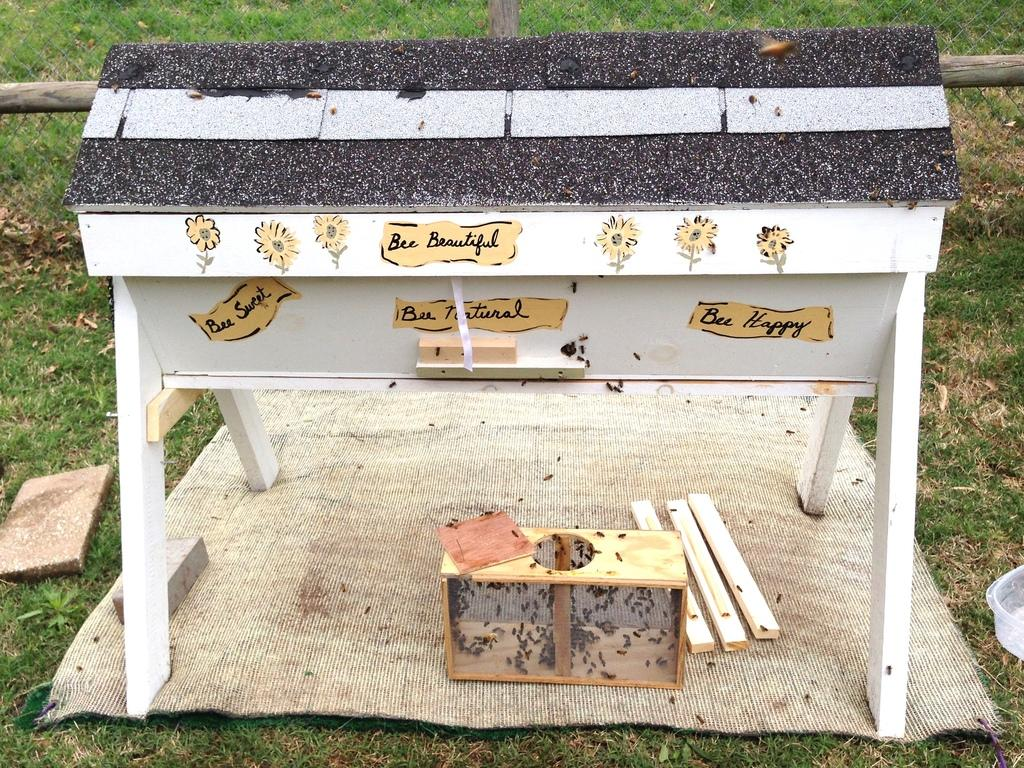<image>
Give a short and clear explanation of the subsequent image. A decorated bee hive with the words Bee Beautiful written in several places. 